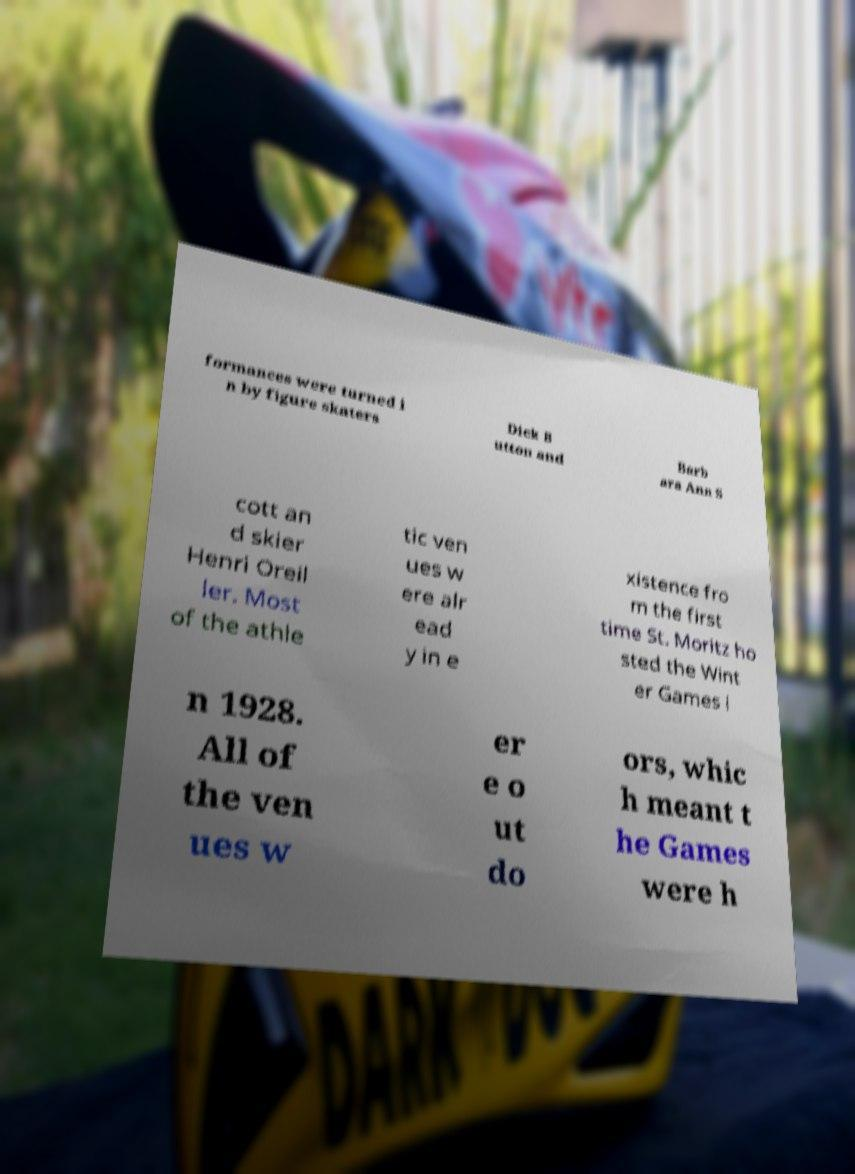Could you extract and type out the text from this image? formances were turned i n by figure skaters Dick B utton and Barb ara Ann S cott an d skier Henri Oreil ler. Most of the athle tic ven ues w ere alr ead y in e xistence fro m the first time St. Moritz ho sted the Wint er Games i n 1928. All of the ven ues w er e o ut do ors, whic h meant t he Games were h 